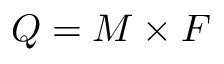<formula> <loc_0><loc_0><loc_500><loc_500>Q = M \times F</formula> 